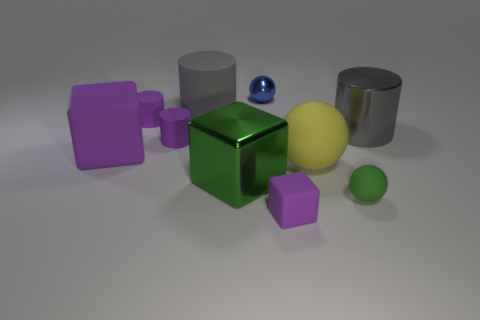There is a large cube right of the matte cylinder in front of the gray cylinder to the right of the small blue ball; what is its material?
Offer a very short reply. Metal. There is a matte thing that is both on the left side of the gray matte thing and behind the large shiny cylinder; how big is it?
Ensure brevity in your answer.  Small. Do the green matte thing and the big yellow rubber thing have the same shape?
Provide a short and direct response. Yes. What shape is the large gray object that is made of the same material as the tiny green ball?
Provide a succinct answer. Cylinder. How many tiny objects are gray cylinders or yellow matte objects?
Ensure brevity in your answer.  0. Are there any tiny rubber objects behind the gray thing right of the big matte cylinder?
Your answer should be compact. Yes. Is there a purple rubber cylinder?
Keep it short and to the point. Yes. What is the color of the tiny shiny ball behind the matte block that is right of the blue thing?
Your answer should be very brief. Blue. What is the material of the small blue thing that is the same shape as the large yellow rubber object?
Your answer should be compact. Metal. How many blue metallic balls have the same size as the metallic cylinder?
Your answer should be very brief. 0. 